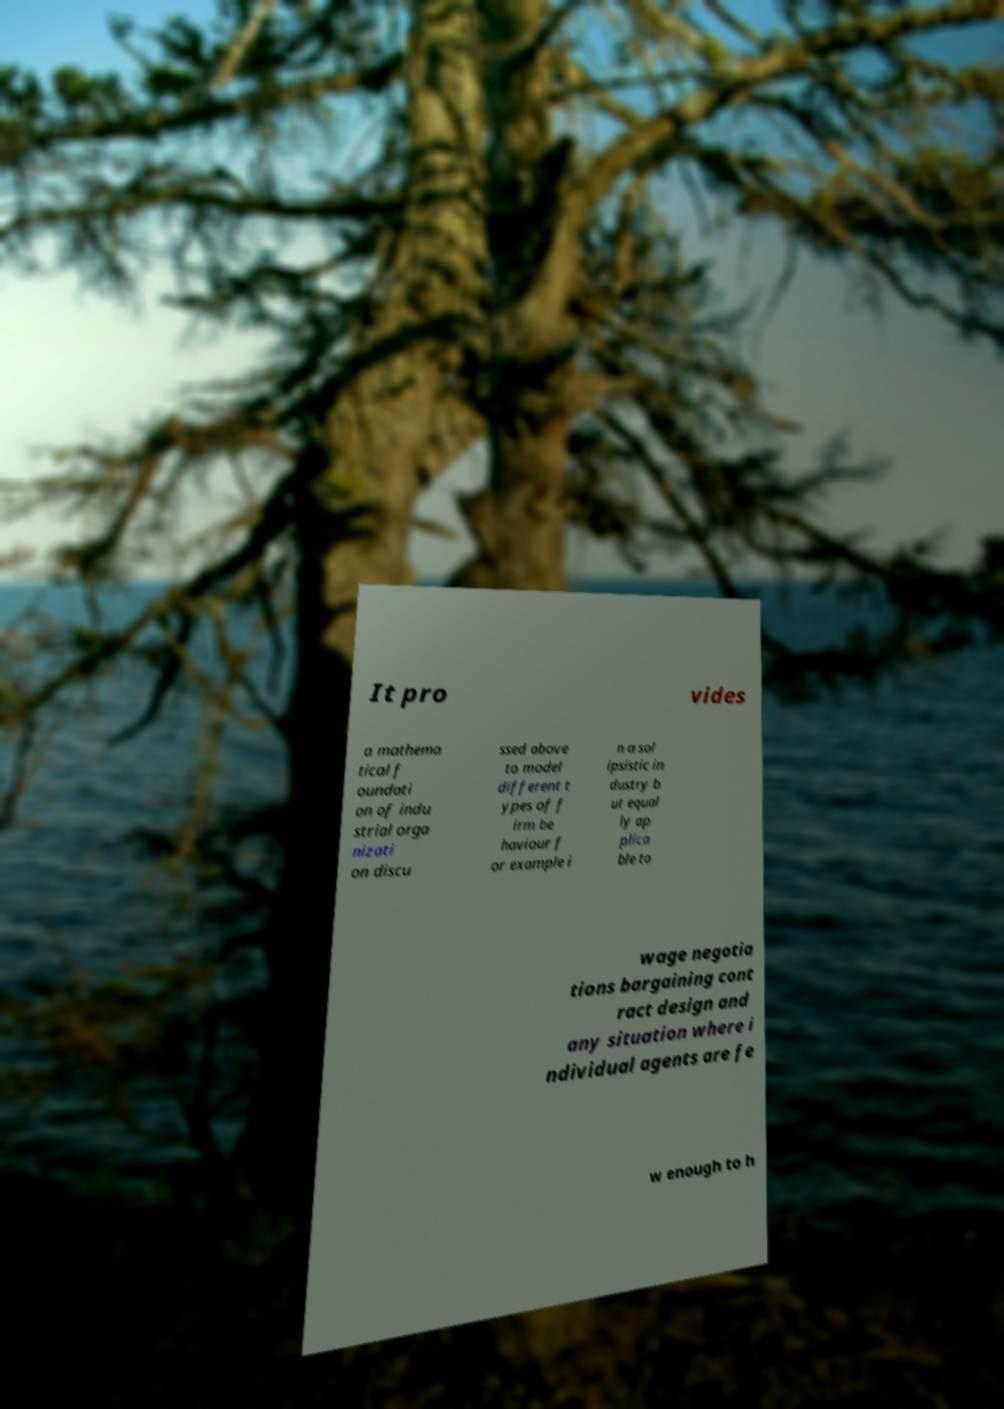Could you extract and type out the text from this image? It pro vides a mathema tical f oundati on of indu strial orga nizati on discu ssed above to model different t ypes of f irm be haviour f or example i n a sol ipsistic in dustry b ut equal ly ap plica ble to wage negotia tions bargaining cont ract design and any situation where i ndividual agents are fe w enough to h 